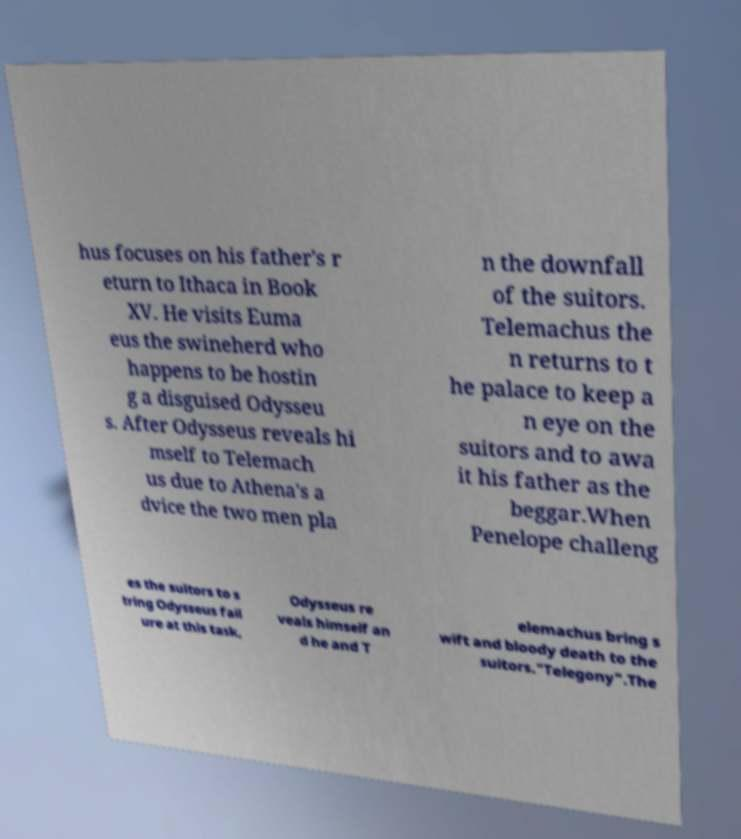Can you accurately transcribe the text from the provided image for me? hus focuses on his father's r eturn to Ithaca in Book XV. He visits Euma eus the swineherd who happens to be hostin g a disguised Odysseu s. After Odysseus reveals hi mself to Telemach us due to Athena's a dvice the two men pla n the downfall of the suitors. Telemachus the n returns to t he palace to keep a n eye on the suitors and to awa it his father as the beggar.When Penelope challeng es the suitors to s tring Odysseus fail ure at this task, Odysseus re veals himself an d he and T elemachus bring s wift and bloody death to the suitors."Telegony".The 